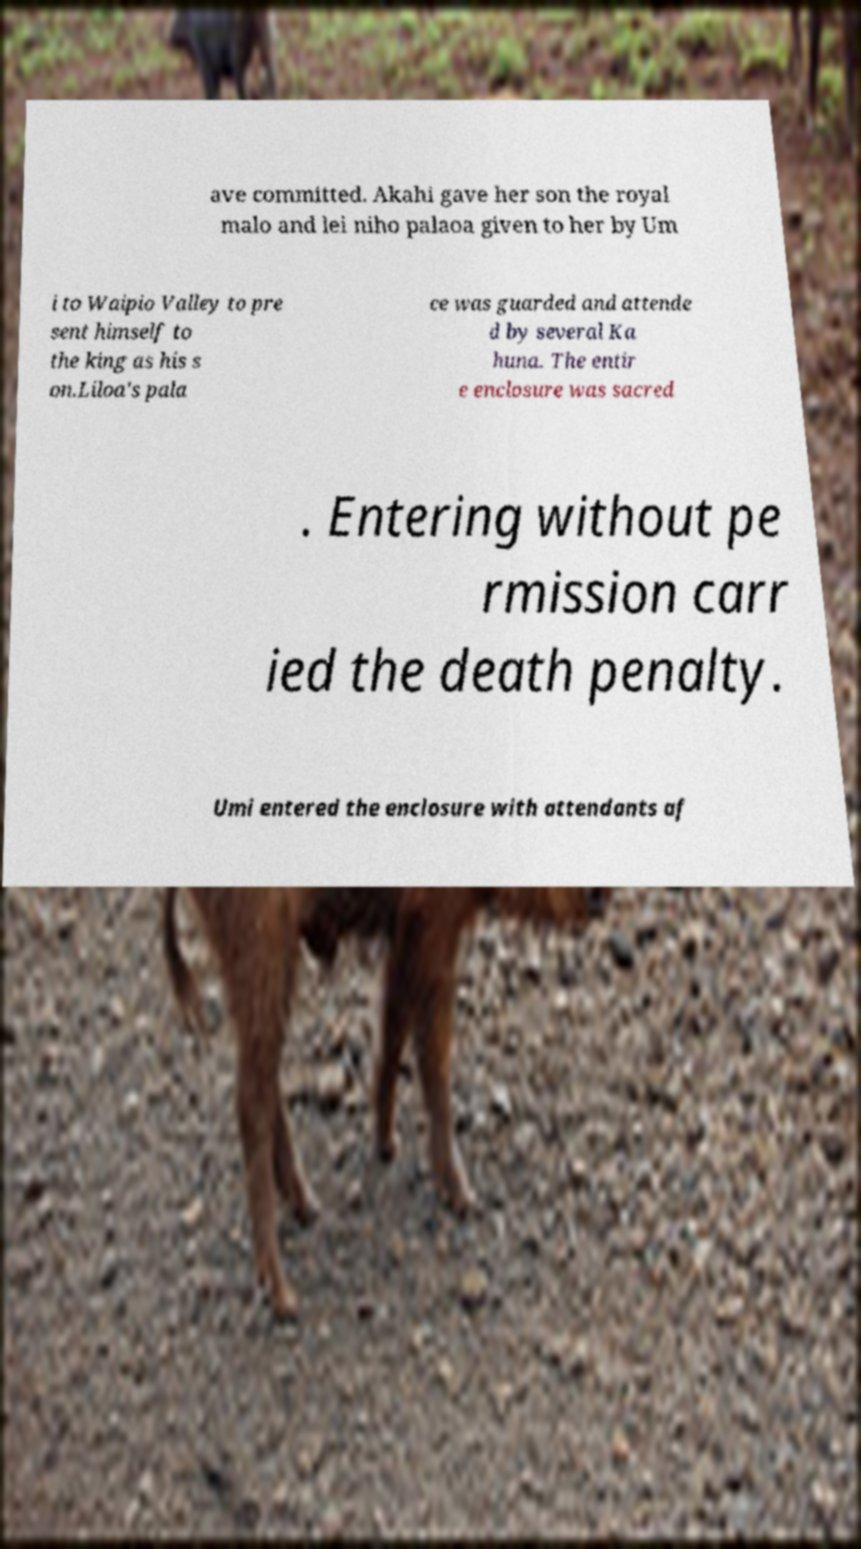Please identify and transcribe the text found in this image. ave committed. Akahi gave her son the royal malo and lei niho palaoa given to her by Um i to Waipio Valley to pre sent himself to the king as his s on.Liloa's pala ce was guarded and attende d by several Ka huna. The entir e enclosure was sacred . Entering without pe rmission carr ied the death penalty. Umi entered the enclosure with attendants af 